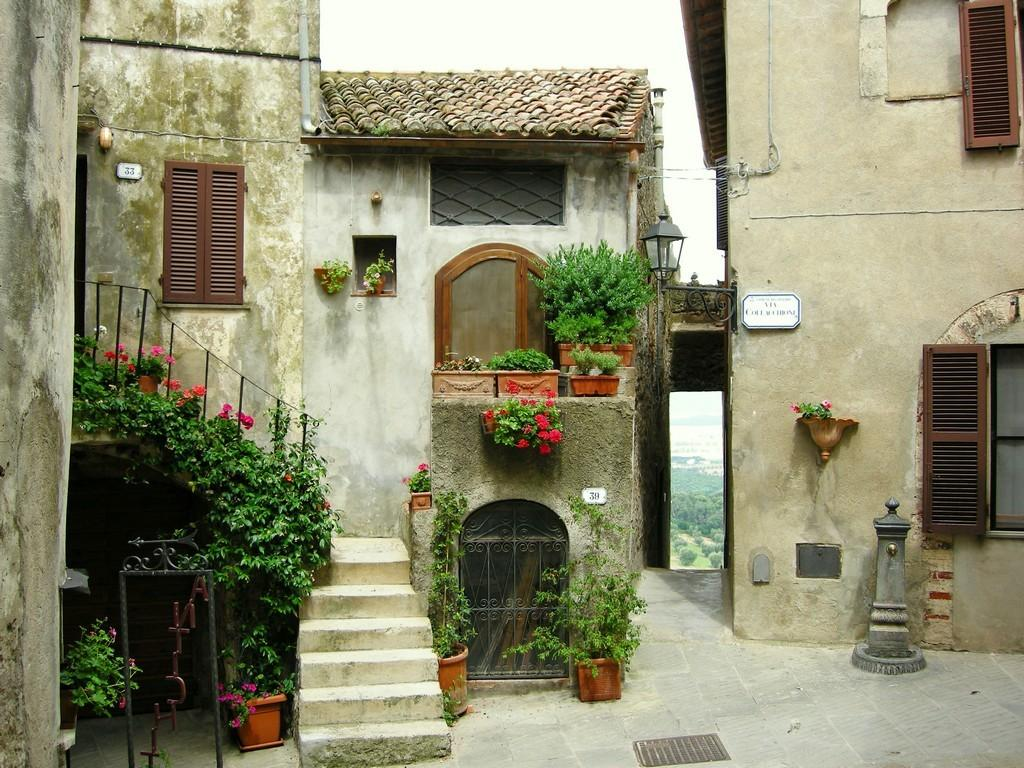What type of structures can be seen in the image? There are buildings in the image. What type of vegetation is present in the image? There are plants, flowers, and trees in the image. What type of containers are visible in the image? There are pots in the image. What architectural features can be seen in the image? There are windows and a roof in the image. What type of surface is visible in the image? There is a floor in the image. What part of the natural environment is visible in the image? The sky is visible in the image. What type of lettuce is growing on the level curve in the image? There is no lettuce present in the image, nor is there any mention of a level curve. 